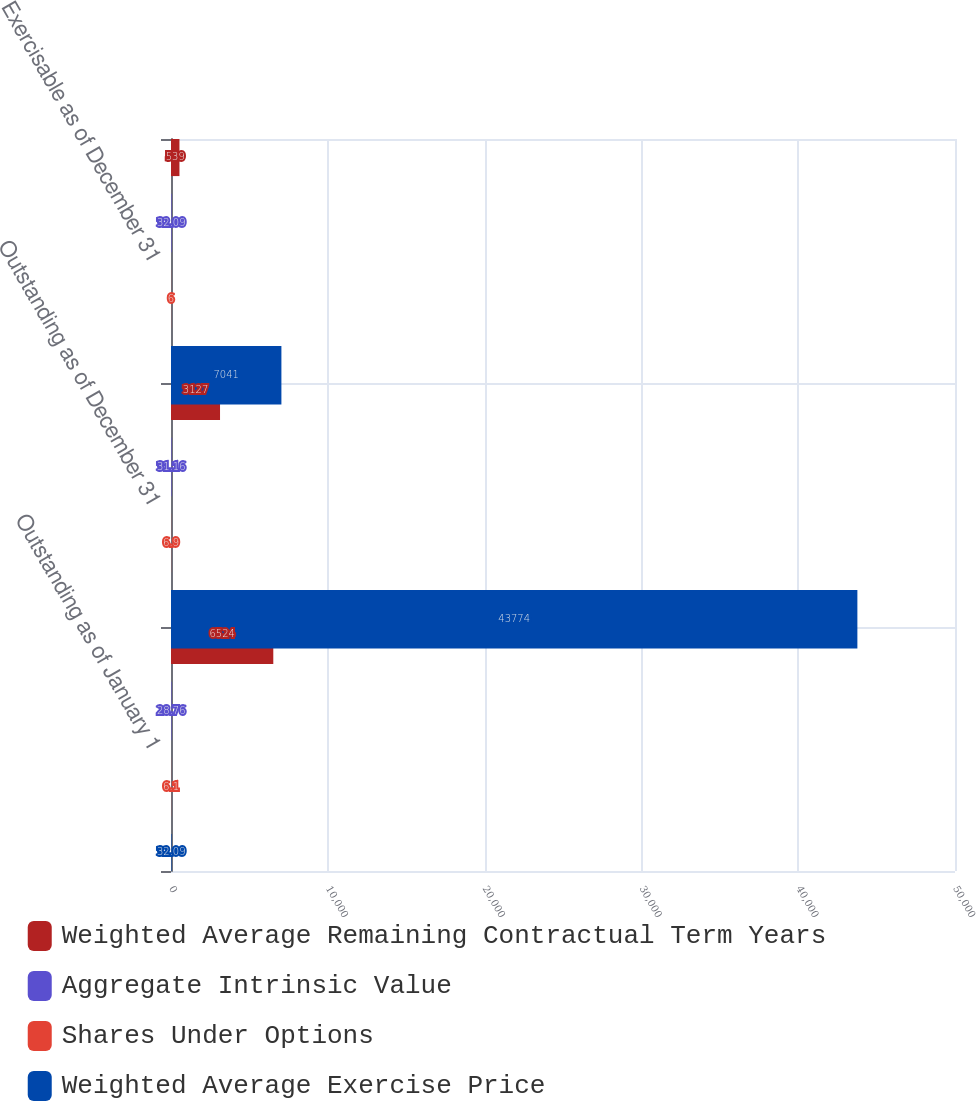<chart> <loc_0><loc_0><loc_500><loc_500><stacked_bar_chart><ecel><fcel>Outstanding as of January 1<fcel>Outstanding as of December 31<fcel>Exercisable as of December 31<nl><fcel>Weighted Average Remaining Contractual Term Years<fcel>6524<fcel>3127<fcel>539<nl><fcel>Aggregate Intrinsic Value<fcel>28.76<fcel>31.16<fcel>32.09<nl><fcel>Shares Under Options<fcel>6.1<fcel>6.9<fcel>6<nl><fcel>Weighted Average Exercise Price<fcel>32.09<fcel>43774<fcel>7041<nl></chart> 